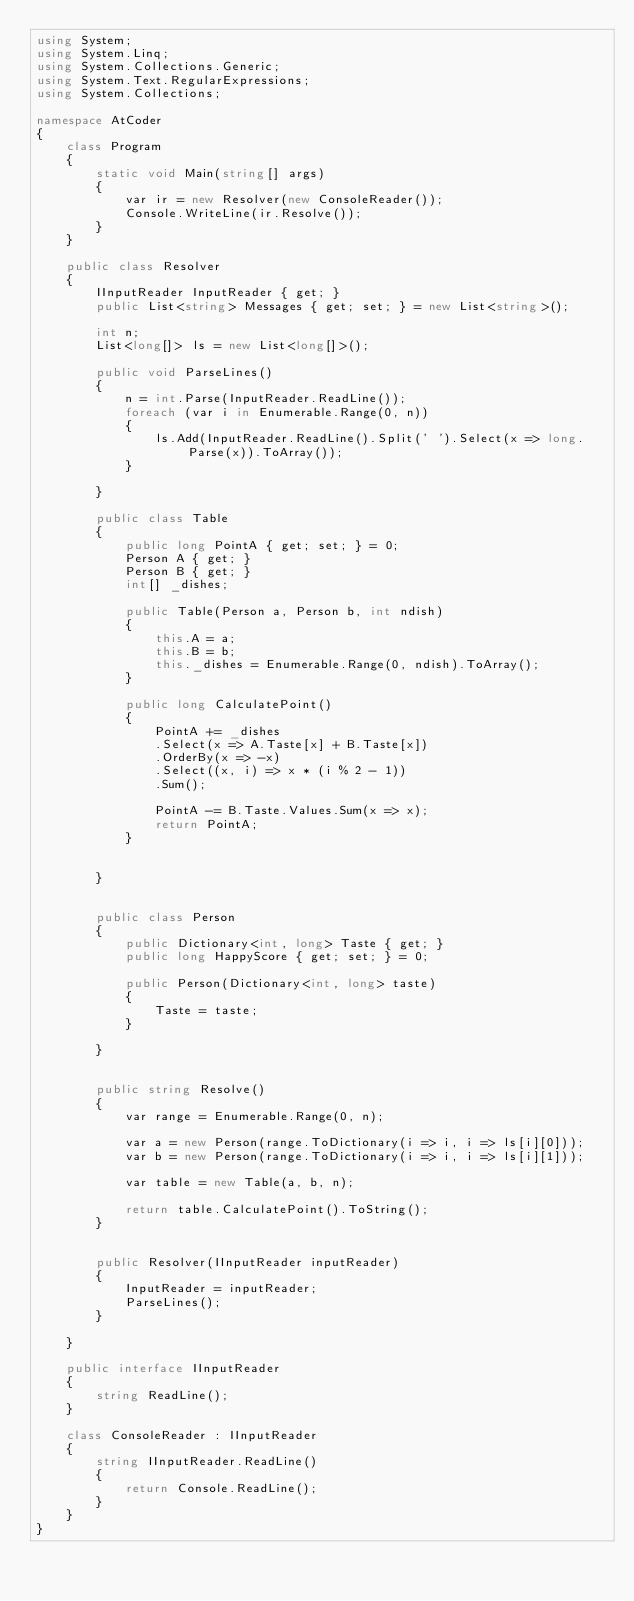Convert code to text. <code><loc_0><loc_0><loc_500><loc_500><_C#_>using System;
using System.Linq;
using System.Collections.Generic;
using System.Text.RegularExpressions;
using System.Collections;

namespace AtCoder
{
    class Program
    {
        static void Main(string[] args)
        {
            var ir = new Resolver(new ConsoleReader());
            Console.WriteLine(ir.Resolve());
        }
    }

    public class Resolver
    {
        IInputReader InputReader { get; }
        public List<string> Messages { get; set; } = new List<string>();

        int n;
        List<long[]> ls = new List<long[]>();

        public void ParseLines()
        {
            n = int.Parse(InputReader.ReadLine());
            foreach (var i in Enumerable.Range(0, n))
            {
                ls.Add(InputReader.ReadLine().Split(' ').Select(x => long.Parse(x)).ToArray());
            }

        }

        public class Table
        {
            public long PointA { get; set; } = 0;
            Person A { get; }
            Person B { get; }
            int[] _dishes;

            public Table(Person a, Person b, int ndish)
            {
                this.A = a;
                this.B = b;
                this._dishes = Enumerable.Range(0, ndish).ToArray();
            }

            public long CalculatePoint()
            {
                PointA += _dishes
                .Select(x => A.Taste[x] + B.Taste[x])
                .OrderBy(x => -x)
                .Select((x, i) => x * (i % 2 - 1))
                .Sum();

                PointA -= B.Taste.Values.Sum(x => x);
                return PointA;
            }


        }


        public class Person
        {
            public Dictionary<int, long> Taste { get; }
            public long HappyScore { get; set; } = 0;

            public Person(Dictionary<int, long> taste)
            {
                Taste = taste;
            }

        }


        public string Resolve()
        {
            var range = Enumerable.Range(0, n);

            var a = new Person(range.ToDictionary(i => i, i => ls[i][0]));
            var b = new Person(range.ToDictionary(i => i, i => ls[i][1]));

            var table = new Table(a, b, n);

            return table.CalculatePoint().ToString();
        }


        public Resolver(IInputReader inputReader)
        {
            InputReader = inputReader;
            ParseLines();
        }

    }

    public interface IInputReader
    {
        string ReadLine();
    }

    class ConsoleReader : IInputReader
    {
        string IInputReader.ReadLine()
        {
            return Console.ReadLine();
        }
    }
}</code> 